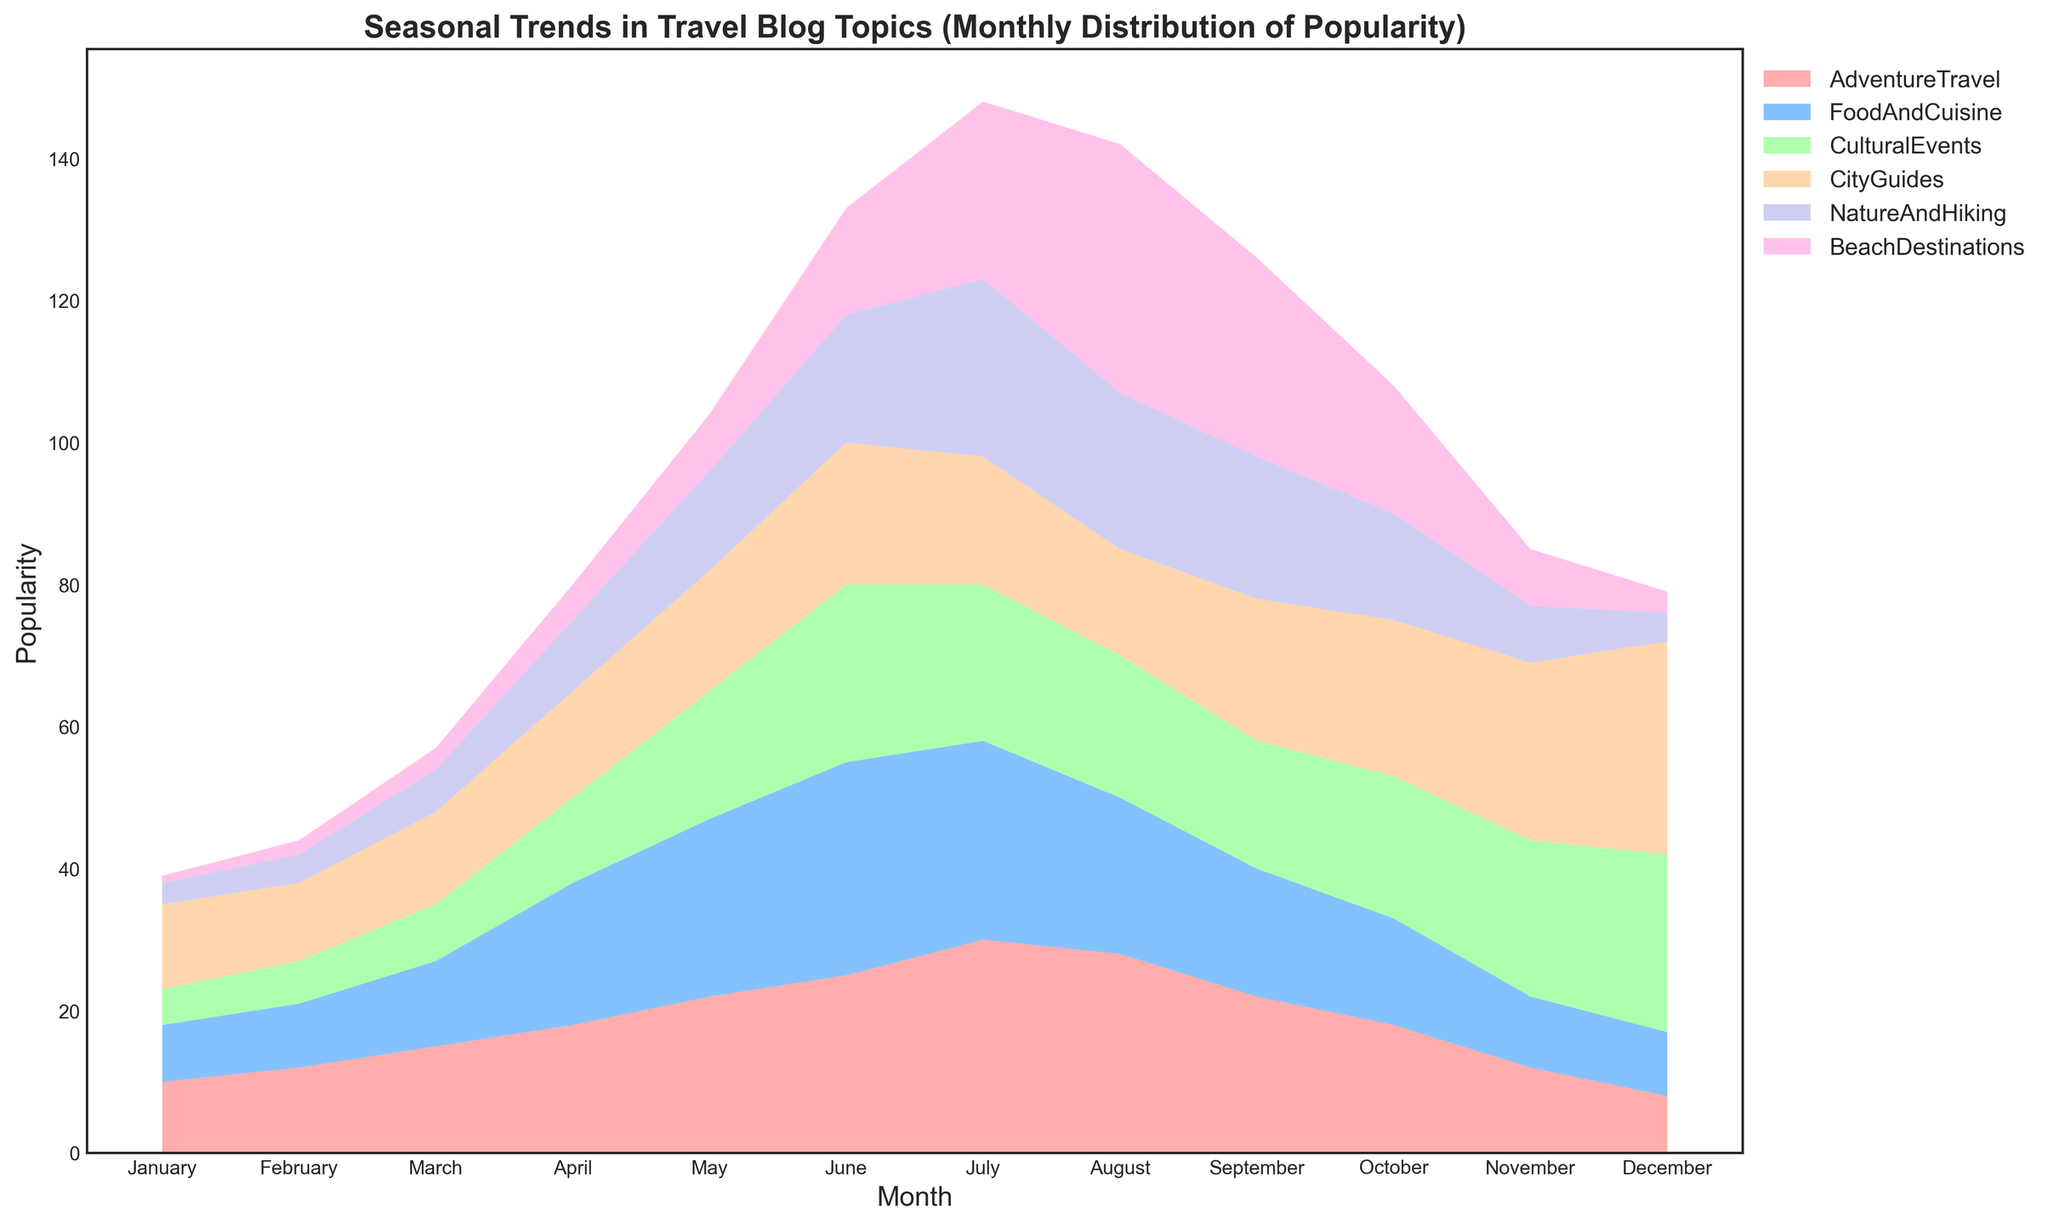what is the month with the highest popularity for Beach Destinations? The chart shows the Beach Destinations trend line peaking highest in August.
Answer: August In which month does Adventure Travel's popularity peak, and what is its value? Adventure Travel reaches its peak popularity in July. The value from the chart is around 30.
Answer: July, 30 Compare the popularity of Food and Cuisine in March and May. Which month is more popular and by how much? In March, Food and Cuisine has a popularity of 12, while in May it has a popularity of 25. The difference is 25 - 12 = 13, with May being the more popular month.
Answer: May, 13 During which month does Cultural Events see the most significant increase in popularity compared to the previous month? The most significant increase in Cultural Events is from March to April, where it goes from 8 in March to 12 in April, an increase of 4. Rather large changes happen later too, but not as significant when considering the relative jump in April.
Answer: April, 4 For which travel topic is there a notable decrease in popularity from July to August? Both Adventure Travel and City Guides show a decrease from July to August, but the most notable drop appears in City Guides, decreasing from 18 to 15.
Answer: City Guides Identify the two months where Nature and Hiking's popularity is equal. What is its popularity value? Nature and Hiking holds a consistent popularity value of 20 in both September and October.
Answer: September and October, 20 Which month shows the highest popularity for City Guides, and how much more popular is it then than in January? City Guides reach their peak in December with a value of 30. Comparing this to January's value of 12, the difference is 30 - 12 = 18.
Answer: December, 18 What's the average popularity of Beach Destinations across the entire year? Adding the popularity values for Beach Destinations across all months (1 + 2 + 3 + 5 + 8 + 15 + 25 + 35 + 28 + 18 + 8 + 3) gives 151. Dividing by 12 (number of months), the average is 151 / 12 ≈ 12.58
Answer: 12.58 What is the total combined popularity for Adventure Travel and Food and Cuisine in June? For June, Adventure Travel has a popularity of 25, and Food and Cuisine has 30. Combined, this is 25 + 30 = 55.
Answer: 55 Between April and October, which month has the highest combined popularity for Nature and Hiking and Beach Destinations? Examining the values between April and October, the highest combined value appears in July. Nature and Hiking has 25, and Beach Destinations has 25 in July, so combined, it is 25 + 25 = 50.
Answer: July, 50 